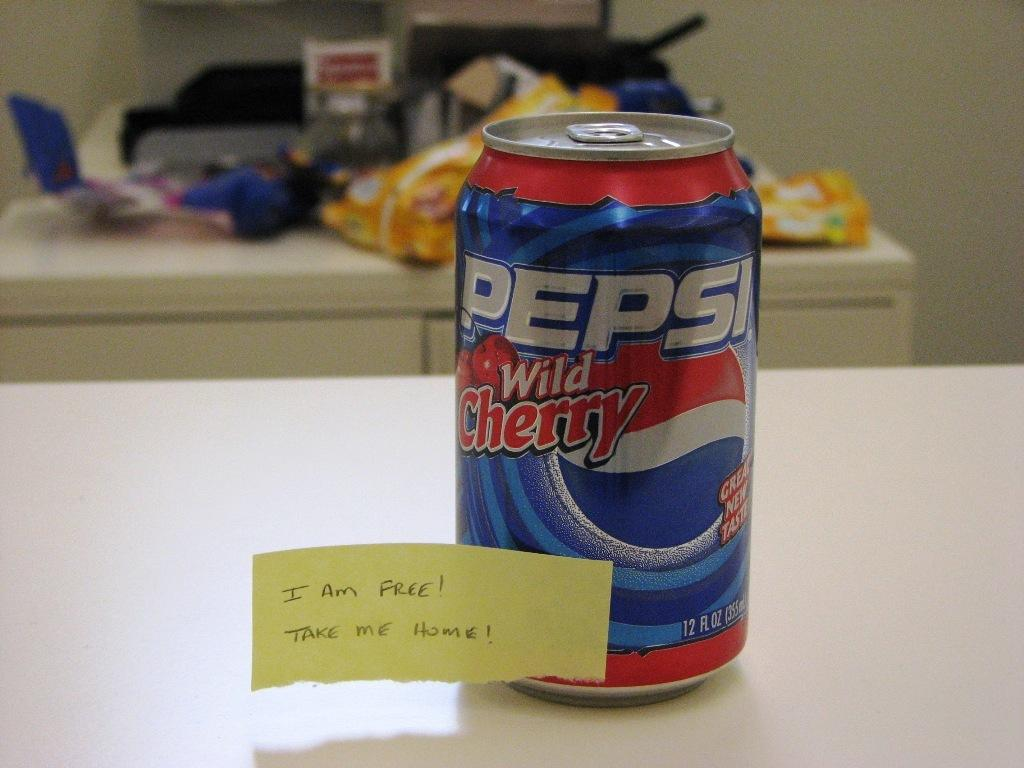<image>
Create a compact narrative representing the image presented. A can of wild cherry flavored Pepsi is on a counter. 